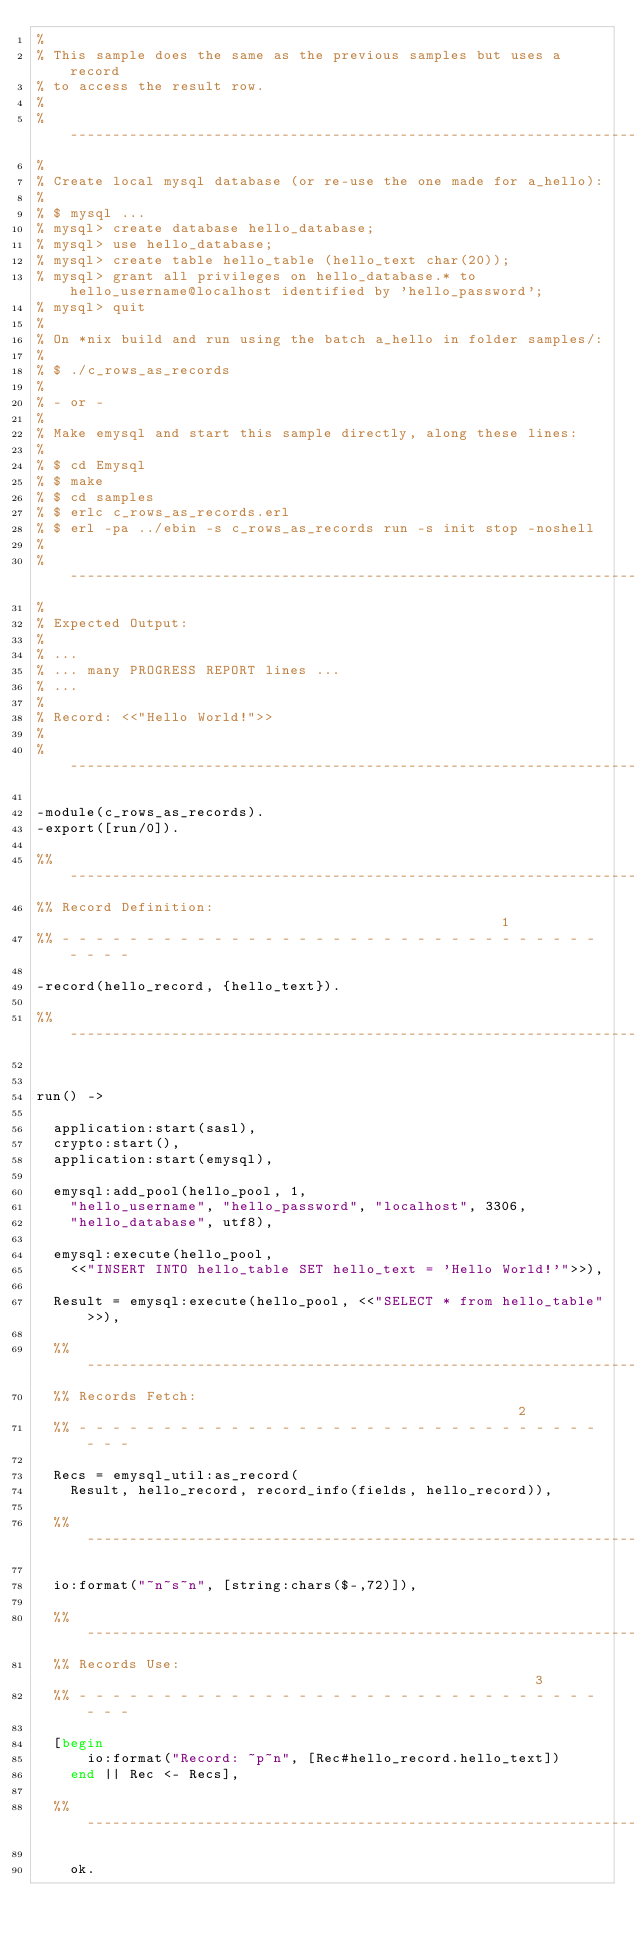Convert code to text. <code><loc_0><loc_0><loc_500><loc_500><_Erlang_>%
% This sample does the same as the previous samples but uses a record
% to access the result row.
%
% ------------------------------------------------------------------------
%
% Create local mysql database (or re-use the one made for a_hello):
%
% $ mysql ...
% mysql> create database hello_database;
% mysql> use hello_database;
% mysql> create table hello_table (hello_text char(20));
% mysql> grant all privileges on hello_database.* to hello_username@localhost identified by 'hello_password';
% mysql> quit
%
% On *nix build and run using the batch a_hello in folder samples/:
%
% $ ./c_rows_as_records
%
% - or - 
%
% Make emysql and start this sample directly, along these lines:
%
% $ cd Emysql
% $ make
% $ cd samples
% $ erlc c_rows_as_records.erl
% $ erl -pa ../ebin -s c_rows_as_records run -s init stop -noshell
%
% ------------------------------------------------------------------------
%
% Expected Output:
%
% ...
% ... many PROGRESS REPORT lines ...
% ...
%
% Record: <<"Hello World!">>
%
% ------------------------------------------------------------------------

-module(c_rows_as_records).
-export([run/0]).

%% -----------------------------------------------------------------------
%% Record Definition:                                                    1
%% - - - - - - - - - - - - - - - - - - - - - - - - - - - - - - - - - - - -

-record(hello_record, {hello_text}).

%% -----------------------------------------------------------------------


run() ->

	application:start(sasl),
	crypto:start(),
	application:start(emysql),

	emysql:add_pool(hello_pool, 1,
		"hello_username", "hello_password", "localhost", 3306,
		"hello_database", utf8),

	emysql:execute(hello_pool,
		<<"INSERT INTO hello_table SET hello_text = 'Hello World!'">>),

	Result = emysql:execute(hello_pool, <<"SELECT * from hello_table">>),

	%% ------------------------------------------------------------------- 
	%% Records Fetch:                                                    2
	%% - - - - - - - - - - - - - - - - - - - - - - - - - - - - - - - - - - 

	Recs = emysql_util:as_record(
		Result, hello_record, record_info(fields, hello_record)),

	%% -------------------------------------------------------------------

	io:format("~n~s~n", [string:chars($-,72)]),

	%% -------------------------------------------------------------------
	%% Records Use:                                                      3
	%% - - - - - - - - - - - - - - - - - - - - - - - - - - - - - - - - - - 

	[begin
      io:format("Record: ~p~n", [Rec#hello_record.hello_text])
    end || Rec <- Recs],
    
	%% -------------------------------------------------------------------

    ok.

</code> 